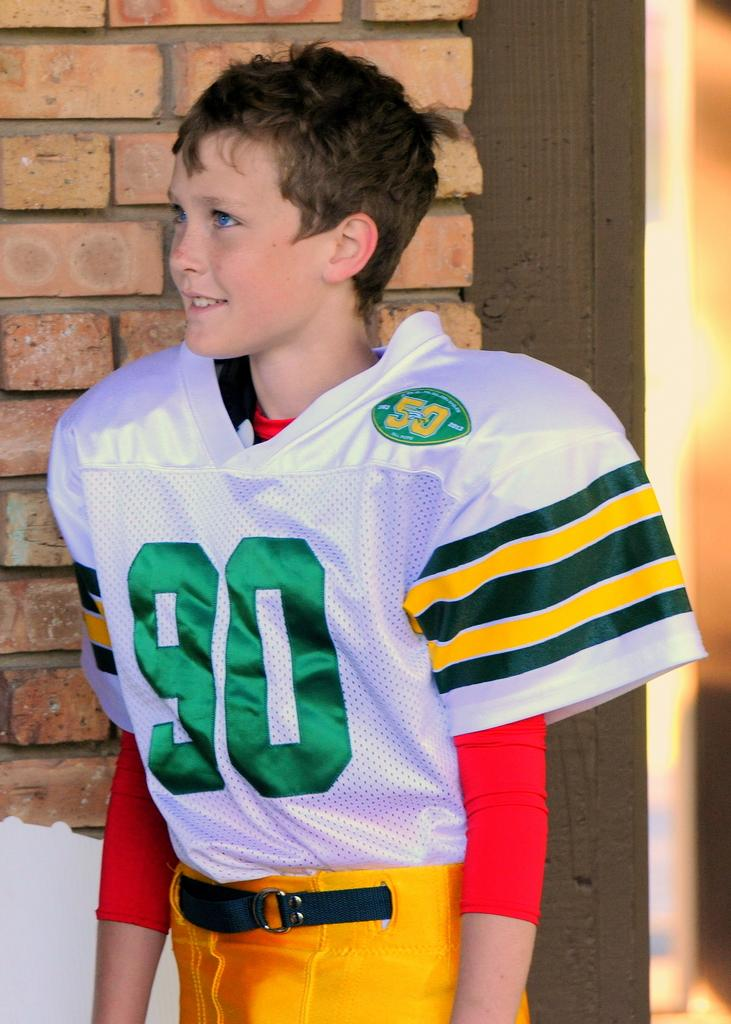<image>
Render a clear and concise summary of the photo. An American football player in a white jersey with 90 in green lettering on the front 